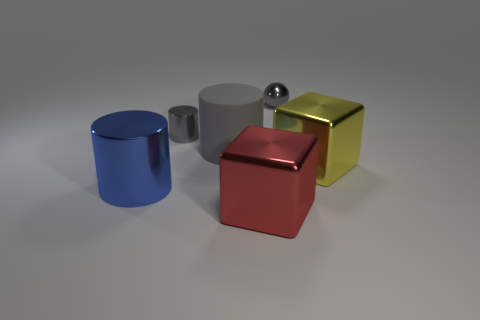Subtract all big blue metal cylinders. How many cylinders are left? 2 Subtract all gray cylinders. How many cylinders are left? 1 Subtract all blocks. How many objects are left? 4 Add 1 big metal cylinders. How many objects exist? 7 Subtract 1 cubes. How many cubes are left? 1 Subtract all large red matte cubes. Subtract all gray spheres. How many objects are left? 5 Add 2 red cubes. How many red cubes are left? 3 Add 2 small metallic spheres. How many small metallic spheres exist? 3 Subtract 0 purple balls. How many objects are left? 6 Subtract all yellow cubes. Subtract all blue cylinders. How many cubes are left? 1 